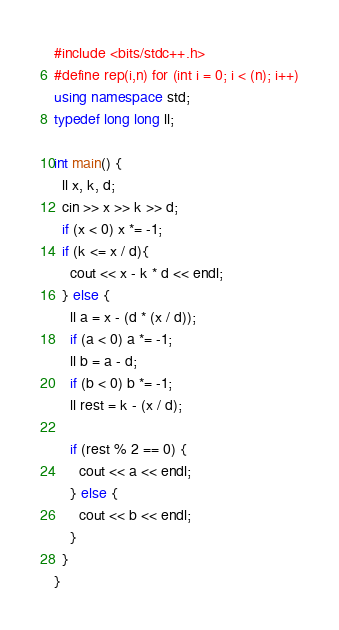<code> <loc_0><loc_0><loc_500><loc_500><_C++_>#include <bits/stdc++.h>
#define rep(i,n) for (int i = 0; i < (n); i++)
using namespace std;
typedef long long ll;

int main() {
  ll x, k, d;
  cin >> x >> k >> d;
  if (x < 0) x *= -1;
  if (k <= x / d){
    cout << x - k * d << endl;
  } else {
    ll a = x - (d * (x / d));
    if (a < 0) a *= -1;
    ll b = a - d;
    if (b < 0) b *= -1;
    ll rest = k - (x / d);

    if (rest % 2 == 0) {
      cout << a << endl;
    } else {
      cout << b << endl;
    }
  }
}
</code> 